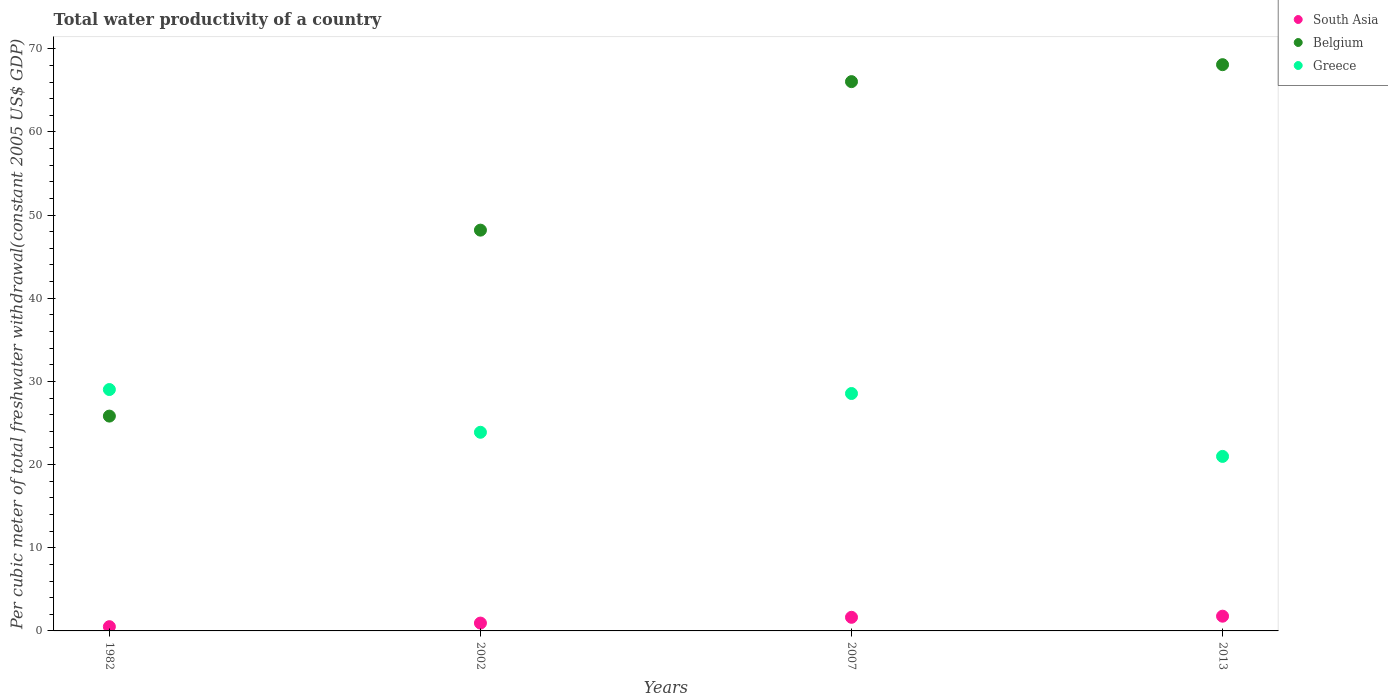Is the number of dotlines equal to the number of legend labels?
Make the answer very short. Yes. What is the total water productivity in South Asia in 2002?
Keep it short and to the point. 0.94. Across all years, what is the maximum total water productivity in Greece?
Provide a succinct answer. 29.02. Across all years, what is the minimum total water productivity in Greece?
Your response must be concise. 20.98. In which year was the total water productivity in Belgium maximum?
Provide a short and direct response. 2013. What is the total total water productivity in Greece in the graph?
Provide a succinct answer. 102.44. What is the difference between the total water productivity in South Asia in 2002 and that in 2013?
Your response must be concise. -0.83. What is the difference between the total water productivity in South Asia in 2007 and the total water productivity in Belgium in 1982?
Offer a terse response. -24.19. What is the average total water productivity in Belgium per year?
Your response must be concise. 52.04. In the year 2002, what is the difference between the total water productivity in South Asia and total water productivity in Greece?
Offer a terse response. -22.94. What is the ratio of the total water productivity in Belgium in 2002 to that in 2007?
Keep it short and to the point. 0.73. Is the difference between the total water productivity in South Asia in 1982 and 2007 greater than the difference between the total water productivity in Greece in 1982 and 2007?
Offer a very short reply. No. What is the difference between the highest and the second highest total water productivity in South Asia?
Keep it short and to the point. 0.13. What is the difference between the highest and the lowest total water productivity in Belgium?
Your response must be concise. 42.25. In how many years, is the total water productivity in Belgium greater than the average total water productivity in Belgium taken over all years?
Provide a succinct answer. 2. Is the sum of the total water productivity in Greece in 1982 and 2007 greater than the maximum total water productivity in Belgium across all years?
Offer a very short reply. No. Is it the case that in every year, the sum of the total water productivity in Greece and total water productivity in Belgium  is greater than the total water productivity in South Asia?
Give a very brief answer. Yes. Does the total water productivity in Greece monotonically increase over the years?
Offer a very short reply. No. How many dotlines are there?
Offer a terse response. 3. How many years are there in the graph?
Offer a terse response. 4. What is the difference between two consecutive major ticks on the Y-axis?
Your answer should be compact. 10. How many legend labels are there?
Keep it short and to the point. 3. What is the title of the graph?
Offer a very short reply. Total water productivity of a country. What is the label or title of the Y-axis?
Provide a succinct answer. Per cubic meter of total freshwater withdrawal(constant 2005 US$ GDP). What is the Per cubic meter of total freshwater withdrawal(constant 2005 US$ GDP) of South Asia in 1982?
Your answer should be very brief. 0.51. What is the Per cubic meter of total freshwater withdrawal(constant 2005 US$ GDP) in Belgium in 1982?
Offer a terse response. 25.83. What is the Per cubic meter of total freshwater withdrawal(constant 2005 US$ GDP) in Greece in 1982?
Offer a terse response. 29.02. What is the Per cubic meter of total freshwater withdrawal(constant 2005 US$ GDP) in South Asia in 2002?
Offer a terse response. 0.94. What is the Per cubic meter of total freshwater withdrawal(constant 2005 US$ GDP) of Belgium in 2002?
Give a very brief answer. 48.19. What is the Per cubic meter of total freshwater withdrawal(constant 2005 US$ GDP) of Greece in 2002?
Offer a very short reply. 23.88. What is the Per cubic meter of total freshwater withdrawal(constant 2005 US$ GDP) of South Asia in 2007?
Your response must be concise. 1.64. What is the Per cubic meter of total freshwater withdrawal(constant 2005 US$ GDP) in Belgium in 2007?
Your answer should be very brief. 66.05. What is the Per cubic meter of total freshwater withdrawal(constant 2005 US$ GDP) in Greece in 2007?
Keep it short and to the point. 28.55. What is the Per cubic meter of total freshwater withdrawal(constant 2005 US$ GDP) of South Asia in 2013?
Your response must be concise. 1.77. What is the Per cubic meter of total freshwater withdrawal(constant 2005 US$ GDP) of Belgium in 2013?
Your response must be concise. 68.08. What is the Per cubic meter of total freshwater withdrawal(constant 2005 US$ GDP) of Greece in 2013?
Your answer should be very brief. 20.98. Across all years, what is the maximum Per cubic meter of total freshwater withdrawal(constant 2005 US$ GDP) of South Asia?
Keep it short and to the point. 1.77. Across all years, what is the maximum Per cubic meter of total freshwater withdrawal(constant 2005 US$ GDP) of Belgium?
Ensure brevity in your answer.  68.08. Across all years, what is the maximum Per cubic meter of total freshwater withdrawal(constant 2005 US$ GDP) in Greece?
Offer a terse response. 29.02. Across all years, what is the minimum Per cubic meter of total freshwater withdrawal(constant 2005 US$ GDP) of South Asia?
Provide a succinct answer. 0.51. Across all years, what is the minimum Per cubic meter of total freshwater withdrawal(constant 2005 US$ GDP) in Belgium?
Keep it short and to the point. 25.83. Across all years, what is the minimum Per cubic meter of total freshwater withdrawal(constant 2005 US$ GDP) in Greece?
Your answer should be very brief. 20.98. What is the total Per cubic meter of total freshwater withdrawal(constant 2005 US$ GDP) of South Asia in the graph?
Keep it short and to the point. 4.86. What is the total Per cubic meter of total freshwater withdrawal(constant 2005 US$ GDP) in Belgium in the graph?
Offer a very short reply. 208.15. What is the total Per cubic meter of total freshwater withdrawal(constant 2005 US$ GDP) of Greece in the graph?
Give a very brief answer. 102.44. What is the difference between the Per cubic meter of total freshwater withdrawal(constant 2005 US$ GDP) in South Asia in 1982 and that in 2002?
Your answer should be very brief. -0.43. What is the difference between the Per cubic meter of total freshwater withdrawal(constant 2005 US$ GDP) in Belgium in 1982 and that in 2002?
Your response must be concise. -22.36. What is the difference between the Per cubic meter of total freshwater withdrawal(constant 2005 US$ GDP) in Greece in 1982 and that in 2002?
Make the answer very short. 5.14. What is the difference between the Per cubic meter of total freshwater withdrawal(constant 2005 US$ GDP) in South Asia in 1982 and that in 2007?
Your response must be concise. -1.13. What is the difference between the Per cubic meter of total freshwater withdrawal(constant 2005 US$ GDP) of Belgium in 1982 and that in 2007?
Your response must be concise. -40.22. What is the difference between the Per cubic meter of total freshwater withdrawal(constant 2005 US$ GDP) of Greece in 1982 and that in 2007?
Offer a terse response. 0.48. What is the difference between the Per cubic meter of total freshwater withdrawal(constant 2005 US$ GDP) of South Asia in 1982 and that in 2013?
Give a very brief answer. -1.26. What is the difference between the Per cubic meter of total freshwater withdrawal(constant 2005 US$ GDP) in Belgium in 1982 and that in 2013?
Provide a short and direct response. -42.25. What is the difference between the Per cubic meter of total freshwater withdrawal(constant 2005 US$ GDP) of Greece in 1982 and that in 2013?
Give a very brief answer. 8.04. What is the difference between the Per cubic meter of total freshwater withdrawal(constant 2005 US$ GDP) of South Asia in 2002 and that in 2007?
Your answer should be very brief. -0.69. What is the difference between the Per cubic meter of total freshwater withdrawal(constant 2005 US$ GDP) in Belgium in 2002 and that in 2007?
Make the answer very short. -17.86. What is the difference between the Per cubic meter of total freshwater withdrawal(constant 2005 US$ GDP) in Greece in 2002 and that in 2007?
Ensure brevity in your answer.  -4.66. What is the difference between the Per cubic meter of total freshwater withdrawal(constant 2005 US$ GDP) in South Asia in 2002 and that in 2013?
Your answer should be very brief. -0.83. What is the difference between the Per cubic meter of total freshwater withdrawal(constant 2005 US$ GDP) of Belgium in 2002 and that in 2013?
Provide a short and direct response. -19.9. What is the difference between the Per cubic meter of total freshwater withdrawal(constant 2005 US$ GDP) of Greece in 2002 and that in 2013?
Your response must be concise. 2.9. What is the difference between the Per cubic meter of total freshwater withdrawal(constant 2005 US$ GDP) of South Asia in 2007 and that in 2013?
Ensure brevity in your answer.  -0.13. What is the difference between the Per cubic meter of total freshwater withdrawal(constant 2005 US$ GDP) of Belgium in 2007 and that in 2013?
Your answer should be very brief. -2.04. What is the difference between the Per cubic meter of total freshwater withdrawal(constant 2005 US$ GDP) of Greece in 2007 and that in 2013?
Your response must be concise. 7.56. What is the difference between the Per cubic meter of total freshwater withdrawal(constant 2005 US$ GDP) in South Asia in 1982 and the Per cubic meter of total freshwater withdrawal(constant 2005 US$ GDP) in Belgium in 2002?
Your answer should be very brief. -47.68. What is the difference between the Per cubic meter of total freshwater withdrawal(constant 2005 US$ GDP) of South Asia in 1982 and the Per cubic meter of total freshwater withdrawal(constant 2005 US$ GDP) of Greece in 2002?
Offer a terse response. -23.37. What is the difference between the Per cubic meter of total freshwater withdrawal(constant 2005 US$ GDP) of Belgium in 1982 and the Per cubic meter of total freshwater withdrawal(constant 2005 US$ GDP) of Greece in 2002?
Give a very brief answer. 1.95. What is the difference between the Per cubic meter of total freshwater withdrawal(constant 2005 US$ GDP) in South Asia in 1982 and the Per cubic meter of total freshwater withdrawal(constant 2005 US$ GDP) in Belgium in 2007?
Your answer should be very brief. -65.53. What is the difference between the Per cubic meter of total freshwater withdrawal(constant 2005 US$ GDP) of South Asia in 1982 and the Per cubic meter of total freshwater withdrawal(constant 2005 US$ GDP) of Greece in 2007?
Provide a succinct answer. -28.04. What is the difference between the Per cubic meter of total freshwater withdrawal(constant 2005 US$ GDP) in Belgium in 1982 and the Per cubic meter of total freshwater withdrawal(constant 2005 US$ GDP) in Greece in 2007?
Ensure brevity in your answer.  -2.72. What is the difference between the Per cubic meter of total freshwater withdrawal(constant 2005 US$ GDP) in South Asia in 1982 and the Per cubic meter of total freshwater withdrawal(constant 2005 US$ GDP) in Belgium in 2013?
Your answer should be compact. -67.57. What is the difference between the Per cubic meter of total freshwater withdrawal(constant 2005 US$ GDP) in South Asia in 1982 and the Per cubic meter of total freshwater withdrawal(constant 2005 US$ GDP) in Greece in 2013?
Provide a short and direct response. -20.47. What is the difference between the Per cubic meter of total freshwater withdrawal(constant 2005 US$ GDP) in Belgium in 1982 and the Per cubic meter of total freshwater withdrawal(constant 2005 US$ GDP) in Greece in 2013?
Your answer should be very brief. 4.85. What is the difference between the Per cubic meter of total freshwater withdrawal(constant 2005 US$ GDP) in South Asia in 2002 and the Per cubic meter of total freshwater withdrawal(constant 2005 US$ GDP) in Belgium in 2007?
Offer a very short reply. -65.1. What is the difference between the Per cubic meter of total freshwater withdrawal(constant 2005 US$ GDP) in South Asia in 2002 and the Per cubic meter of total freshwater withdrawal(constant 2005 US$ GDP) in Greece in 2007?
Ensure brevity in your answer.  -27.6. What is the difference between the Per cubic meter of total freshwater withdrawal(constant 2005 US$ GDP) in Belgium in 2002 and the Per cubic meter of total freshwater withdrawal(constant 2005 US$ GDP) in Greece in 2007?
Make the answer very short. 19.64. What is the difference between the Per cubic meter of total freshwater withdrawal(constant 2005 US$ GDP) in South Asia in 2002 and the Per cubic meter of total freshwater withdrawal(constant 2005 US$ GDP) in Belgium in 2013?
Offer a very short reply. -67.14. What is the difference between the Per cubic meter of total freshwater withdrawal(constant 2005 US$ GDP) in South Asia in 2002 and the Per cubic meter of total freshwater withdrawal(constant 2005 US$ GDP) in Greece in 2013?
Give a very brief answer. -20.04. What is the difference between the Per cubic meter of total freshwater withdrawal(constant 2005 US$ GDP) in Belgium in 2002 and the Per cubic meter of total freshwater withdrawal(constant 2005 US$ GDP) in Greece in 2013?
Make the answer very short. 27.2. What is the difference between the Per cubic meter of total freshwater withdrawal(constant 2005 US$ GDP) of South Asia in 2007 and the Per cubic meter of total freshwater withdrawal(constant 2005 US$ GDP) of Belgium in 2013?
Keep it short and to the point. -66.45. What is the difference between the Per cubic meter of total freshwater withdrawal(constant 2005 US$ GDP) in South Asia in 2007 and the Per cubic meter of total freshwater withdrawal(constant 2005 US$ GDP) in Greece in 2013?
Your answer should be very brief. -19.35. What is the difference between the Per cubic meter of total freshwater withdrawal(constant 2005 US$ GDP) of Belgium in 2007 and the Per cubic meter of total freshwater withdrawal(constant 2005 US$ GDP) of Greece in 2013?
Offer a very short reply. 45.06. What is the average Per cubic meter of total freshwater withdrawal(constant 2005 US$ GDP) in South Asia per year?
Give a very brief answer. 1.22. What is the average Per cubic meter of total freshwater withdrawal(constant 2005 US$ GDP) of Belgium per year?
Your response must be concise. 52.04. What is the average Per cubic meter of total freshwater withdrawal(constant 2005 US$ GDP) of Greece per year?
Your answer should be very brief. 25.61. In the year 1982, what is the difference between the Per cubic meter of total freshwater withdrawal(constant 2005 US$ GDP) in South Asia and Per cubic meter of total freshwater withdrawal(constant 2005 US$ GDP) in Belgium?
Offer a very short reply. -25.32. In the year 1982, what is the difference between the Per cubic meter of total freshwater withdrawal(constant 2005 US$ GDP) in South Asia and Per cubic meter of total freshwater withdrawal(constant 2005 US$ GDP) in Greece?
Provide a short and direct response. -28.51. In the year 1982, what is the difference between the Per cubic meter of total freshwater withdrawal(constant 2005 US$ GDP) in Belgium and Per cubic meter of total freshwater withdrawal(constant 2005 US$ GDP) in Greece?
Offer a terse response. -3.19. In the year 2002, what is the difference between the Per cubic meter of total freshwater withdrawal(constant 2005 US$ GDP) in South Asia and Per cubic meter of total freshwater withdrawal(constant 2005 US$ GDP) in Belgium?
Your answer should be very brief. -47.25. In the year 2002, what is the difference between the Per cubic meter of total freshwater withdrawal(constant 2005 US$ GDP) in South Asia and Per cubic meter of total freshwater withdrawal(constant 2005 US$ GDP) in Greece?
Make the answer very short. -22.94. In the year 2002, what is the difference between the Per cubic meter of total freshwater withdrawal(constant 2005 US$ GDP) in Belgium and Per cubic meter of total freshwater withdrawal(constant 2005 US$ GDP) in Greece?
Offer a terse response. 24.3. In the year 2007, what is the difference between the Per cubic meter of total freshwater withdrawal(constant 2005 US$ GDP) in South Asia and Per cubic meter of total freshwater withdrawal(constant 2005 US$ GDP) in Belgium?
Your answer should be very brief. -64.41. In the year 2007, what is the difference between the Per cubic meter of total freshwater withdrawal(constant 2005 US$ GDP) of South Asia and Per cubic meter of total freshwater withdrawal(constant 2005 US$ GDP) of Greece?
Make the answer very short. -26.91. In the year 2007, what is the difference between the Per cubic meter of total freshwater withdrawal(constant 2005 US$ GDP) in Belgium and Per cubic meter of total freshwater withdrawal(constant 2005 US$ GDP) in Greece?
Make the answer very short. 37.5. In the year 2013, what is the difference between the Per cubic meter of total freshwater withdrawal(constant 2005 US$ GDP) of South Asia and Per cubic meter of total freshwater withdrawal(constant 2005 US$ GDP) of Belgium?
Your response must be concise. -66.31. In the year 2013, what is the difference between the Per cubic meter of total freshwater withdrawal(constant 2005 US$ GDP) of South Asia and Per cubic meter of total freshwater withdrawal(constant 2005 US$ GDP) of Greece?
Offer a terse response. -19.21. In the year 2013, what is the difference between the Per cubic meter of total freshwater withdrawal(constant 2005 US$ GDP) of Belgium and Per cubic meter of total freshwater withdrawal(constant 2005 US$ GDP) of Greece?
Your response must be concise. 47.1. What is the ratio of the Per cubic meter of total freshwater withdrawal(constant 2005 US$ GDP) of South Asia in 1982 to that in 2002?
Make the answer very short. 0.54. What is the ratio of the Per cubic meter of total freshwater withdrawal(constant 2005 US$ GDP) of Belgium in 1982 to that in 2002?
Ensure brevity in your answer.  0.54. What is the ratio of the Per cubic meter of total freshwater withdrawal(constant 2005 US$ GDP) of Greece in 1982 to that in 2002?
Give a very brief answer. 1.22. What is the ratio of the Per cubic meter of total freshwater withdrawal(constant 2005 US$ GDP) of South Asia in 1982 to that in 2007?
Make the answer very short. 0.31. What is the ratio of the Per cubic meter of total freshwater withdrawal(constant 2005 US$ GDP) of Belgium in 1982 to that in 2007?
Offer a terse response. 0.39. What is the ratio of the Per cubic meter of total freshwater withdrawal(constant 2005 US$ GDP) in Greece in 1982 to that in 2007?
Offer a terse response. 1.02. What is the ratio of the Per cubic meter of total freshwater withdrawal(constant 2005 US$ GDP) of South Asia in 1982 to that in 2013?
Offer a very short reply. 0.29. What is the ratio of the Per cubic meter of total freshwater withdrawal(constant 2005 US$ GDP) of Belgium in 1982 to that in 2013?
Your answer should be compact. 0.38. What is the ratio of the Per cubic meter of total freshwater withdrawal(constant 2005 US$ GDP) of Greece in 1982 to that in 2013?
Offer a terse response. 1.38. What is the ratio of the Per cubic meter of total freshwater withdrawal(constant 2005 US$ GDP) in South Asia in 2002 to that in 2007?
Make the answer very short. 0.58. What is the ratio of the Per cubic meter of total freshwater withdrawal(constant 2005 US$ GDP) in Belgium in 2002 to that in 2007?
Give a very brief answer. 0.73. What is the ratio of the Per cubic meter of total freshwater withdrawal(constant 2005 US$ GDP) in Greece in 2002 to that in 2007?
Offer a terse response. 0.84. What is the ratio of the Per cubic meter of total freshwater withdrawal(constant 2005 US$ GDP) of South Asia in 2002 to that in 2013?
Provide a succinct answer. 0.53. What is the ratio of the Per cubic meter of total freshwater withdrawal(constant 2005 US$ GDP) of Belgium in 2002 to that in 2013?
Provide a succinct answer. 0.71. What is the ratio of the Per cubic meter of total freshwater withdrawal(constant 2005 US$ GDP) in Greece in 2002 to that in 2013?
Make the answer very short. 1.14. What is the ratio of the Per cubic meter of total freshwater withdrawal(constant 2005 US$ GDP) of South Asia in 2007 to that in 2013?
Your answer should be compact. 0.92. What is the ratio of the Per cubic meter of total freshwater withdrawal(constant 2005 US$ GDP) in Belgium in 2007 to that in 2013?
Make the answer very short. 0.97. What is the ratio of the Per cubic meter of total freshwater withdrawal(constant 2005 US$ GDP) of Greece in 2007 to that in 2013?
Give a very brief answer. 1.36. What is the difference between the highest and the second highest Per cubic meter of total freshwater withdrawal(constant 2005 US$ GDP) in South Asia?
Your response must be concise. 0.13. What is the difference between the highest and the second highest Per cubic meter of total freshwater withdrawal(constant 2005 US$ GDP) of Belgium?
Provide a succinct answer. 2.04. What is the difference between the highest and the second highest Per cubic meter of total freshwater withdrawal(constant 2005 US$ GDP) of Greece?
Provide a succinct answer. 0.48. What is the difference between the highest and the lowest Per cubic meter of total freshwater withdrawal(constant 2005 US$ GDP) in South Asia?
Provide a succinct answer. 1.26. What is the difference between the highest and the lowest Per cubic meter of total freshwater withdrawal(constant 2005 US$ GDP) in Belgium?
Ensure brevity in your answer.  42.25. What is the difference between the highest and the lowest Per cubic meter of total freshwater withdrawal(constant 2005 US$ GDP) in Greece?
Give a very brief answer. 8.04. 